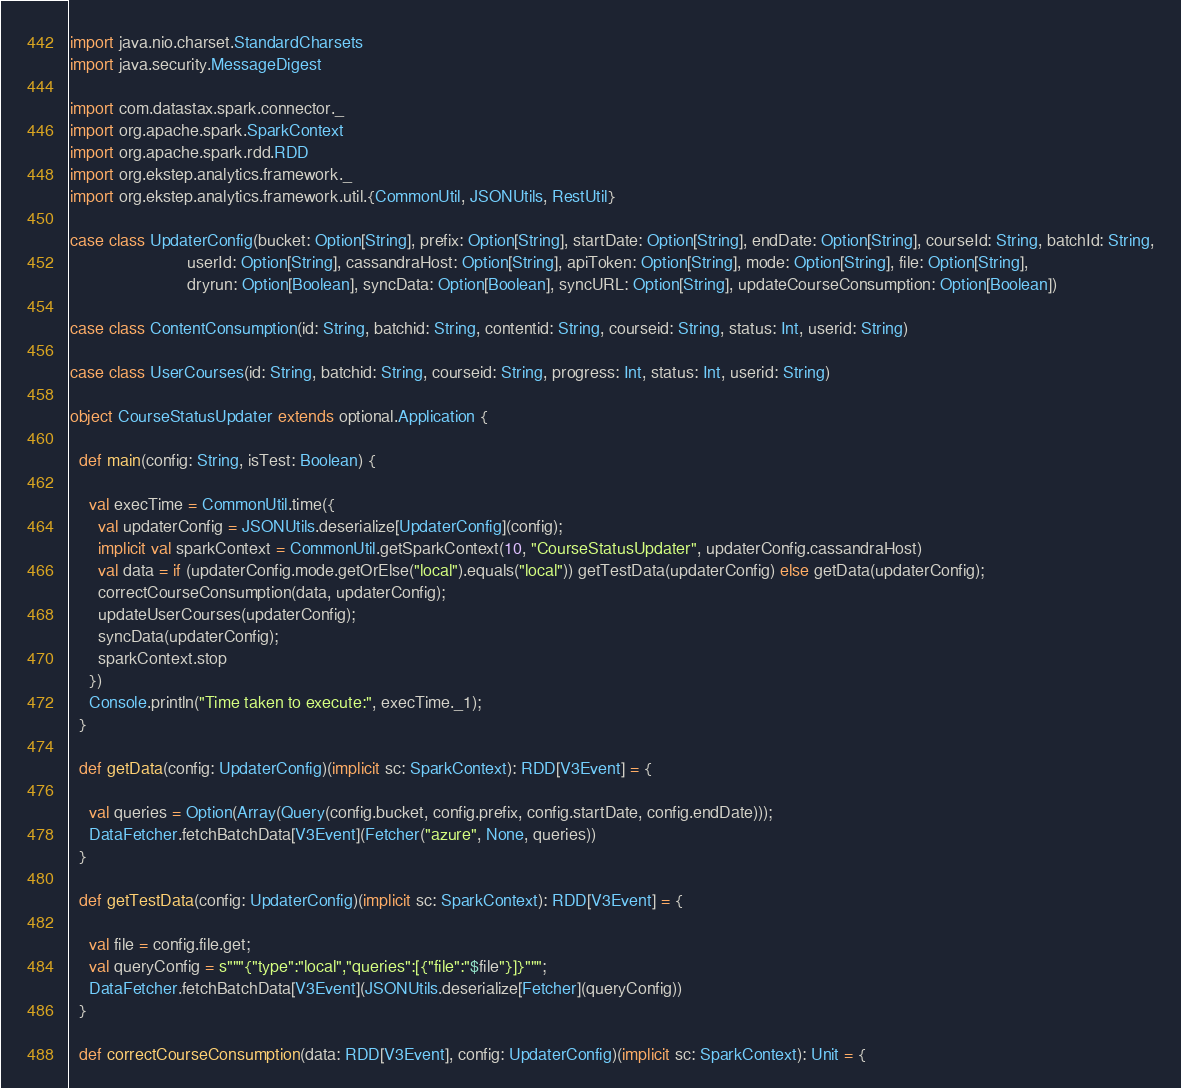Convert code to text. <code><loc_0><loc_0><loc_500><loc_500><_Scala_>import java.nio.charset.StandardCharsets
import java.security.MessageDigest

import com.datastax.spark.connector._
import org.apache.spark.SparkContext
import org.apache.spark.rdd.RDD
import org.ekstep.analytics.framework._
import org.ekstep.analytics.framework.util.{CommonUtil, JSONUtils, RestUtil}

case class UpdaterConfig(bucket: Option[String], prefix: Option[String], startDate: Option[String], endDate: Option[String], courseId: String, batchId: String,
                         userId: Option[String], cassandraHost: Option[String], apiToken: Option[String], mode: Option[String], file: Option[String],
                         dryrun: Option[Boolean], syncData: Option[Boolean], syncURL: Option[String], updateCourseConsumption: Option[Boolean])

case class ContentConsumption(id: String, batchid: String, contentid: String, courseid: String, status: Int, userid: String)

case class UserCourses(id: String, batchid: String, courseid: String, progress: Int, status: Int, userid: String)

object CourseStatusUpdater extends optional.Application {

  def main(config: String, isTest: Boolean) {

    val execTime = CommonUtil.time({
      val updaterConfig = JSONUtils.deserialize[UpdaterConfig](config);
      implicit val sparkContext = CommonUtil.getSparkContext(10, "CourseStatusUpdater", updaterConfig.cassandraHost)
      val data = if (updaterConfig.mode.getOrElse("local").equals("local")) getTestData(updaterConfig) else getData(updaterConfig);
      correctCourseConsumption(data, updaterConfig);
      updateUserCourses(updaterConfig);
      syncData(updaterConfig);
      sparkContext.stop
    })
    Console.println("Time taken to execute:", execTime._1);
  }

  def getData(config: UpdaterConfig)(implicit sc: SparkContext): RDD[V3Event] = {

    val queries = Option(Array(Query(config.bucket, config.prefix, config.startDate, config.endDate)));
    DataFetcher.fetchBatchData[V3Event](Fetcher("azure", None, queries))
  }

  def getTestData(config: UpdaterConfig)(implicit sc: SparkContext): RDD[V3Event] = {

    val file = config.file.get;
    val queryConfig = s"""{"type":"local","queries":[{"file":"$file"}]}""";
    DataFetcher.fetchBatchData[V3Event](JSONUtils.deserialize[Fetcher](queryConfig))
  }

  def correctCourseConsumption(data: RDD[V3Event], config: UpdaterConfig)(implicit sc: SparkContext): Unit = {
</code> 